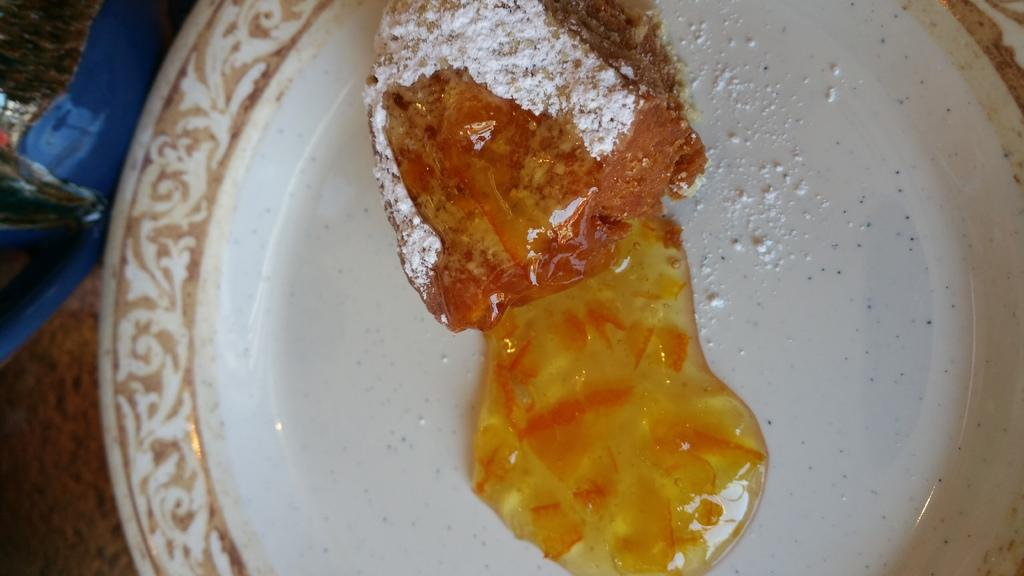What is present on the plate in the image? There are food items on the plate in the image. Where is the plate located? The plate is on a table. How many frogs can be seen jumping on the mountain in the image? There are no frogs or mountains present in the image. 